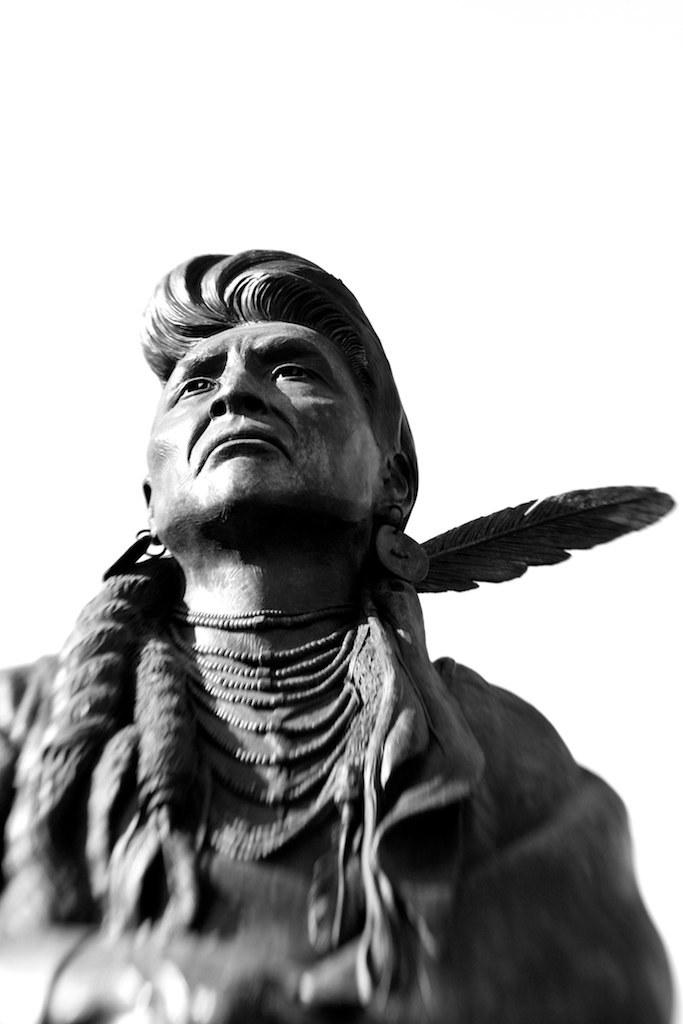What is located at the bottom of the image? There is a statue of a person at the bottom of the image. What color is the background of the image? The background of the image is white in color. How many potatoes are stacked on the coil in the image? There are no potatoes or coils present in the image. What type of books can be seen in the library in the image? There is no library present in the image. 